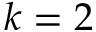<formula> <loc_0><loc_0><loc_500><loc_500>k = 2</formula> 